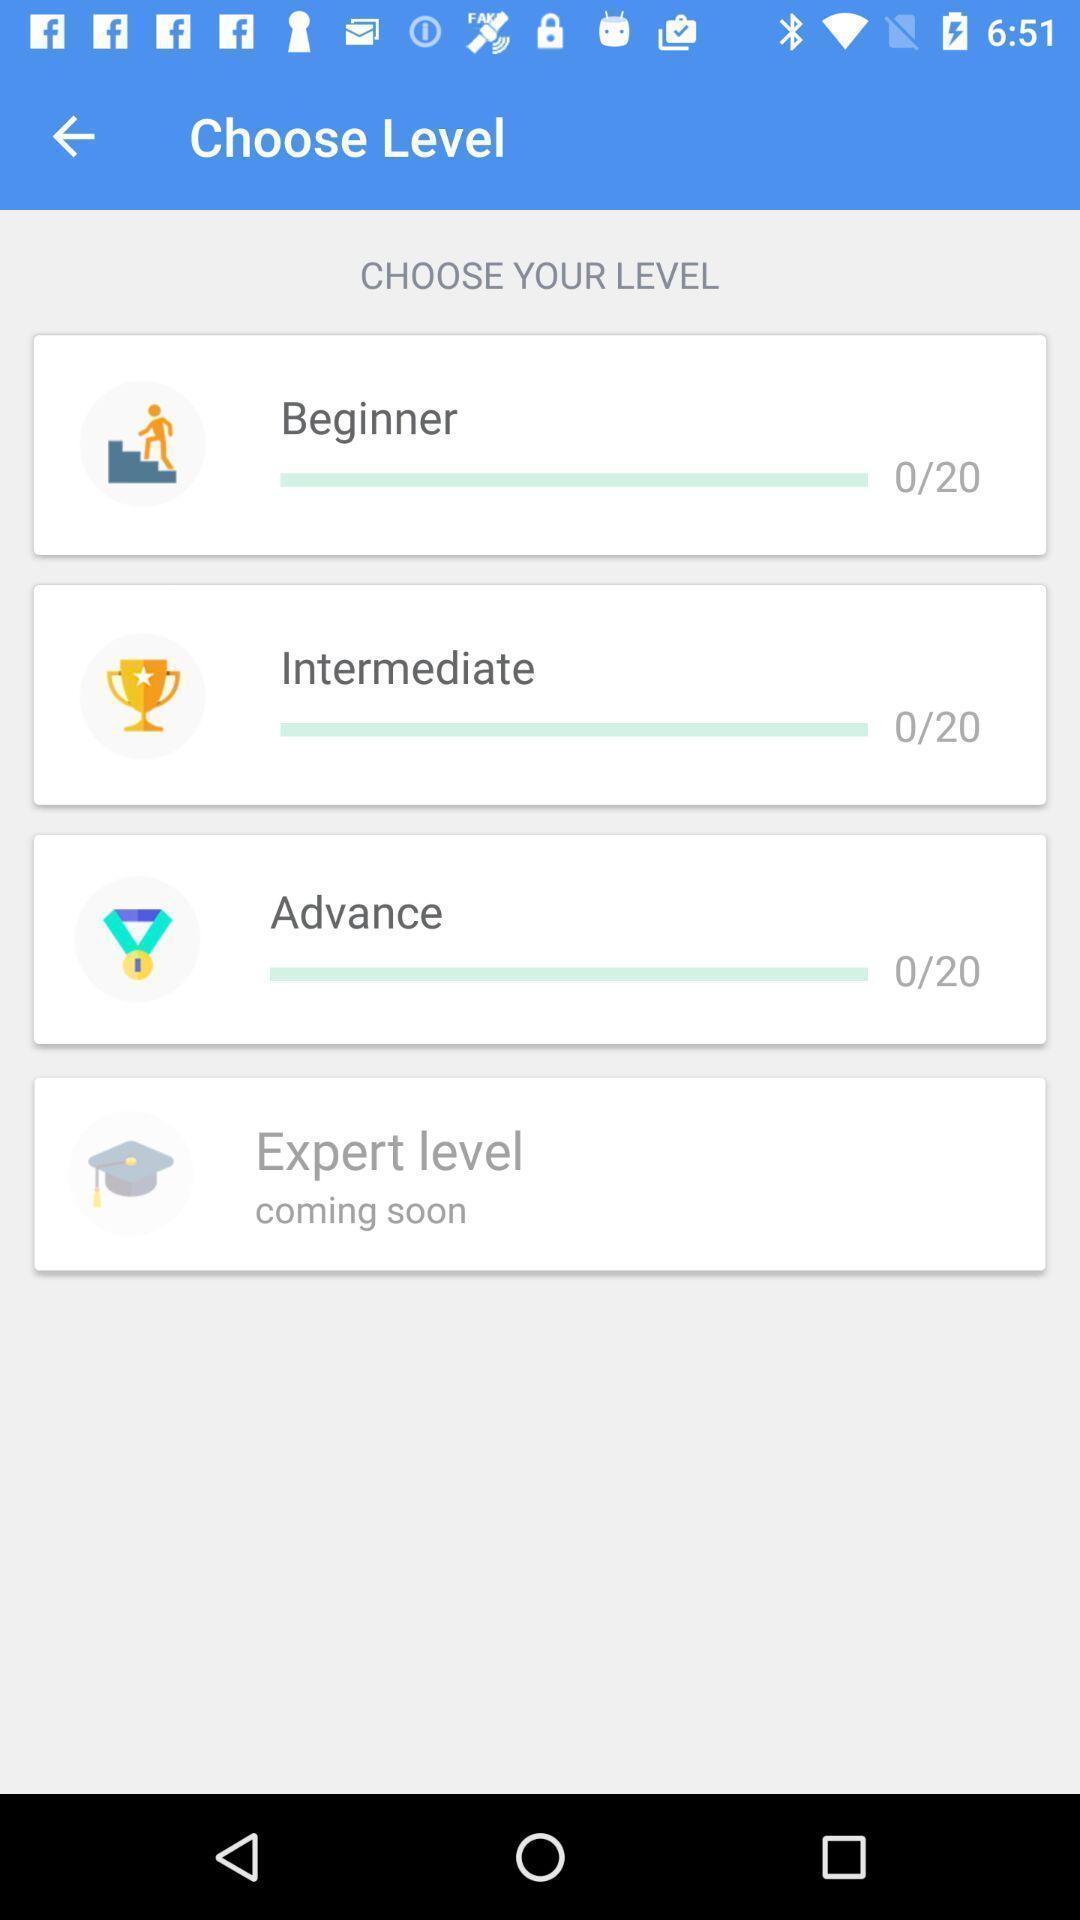Describe the visual elements of this screenshot. Page to select the level in an vocabulary app. 